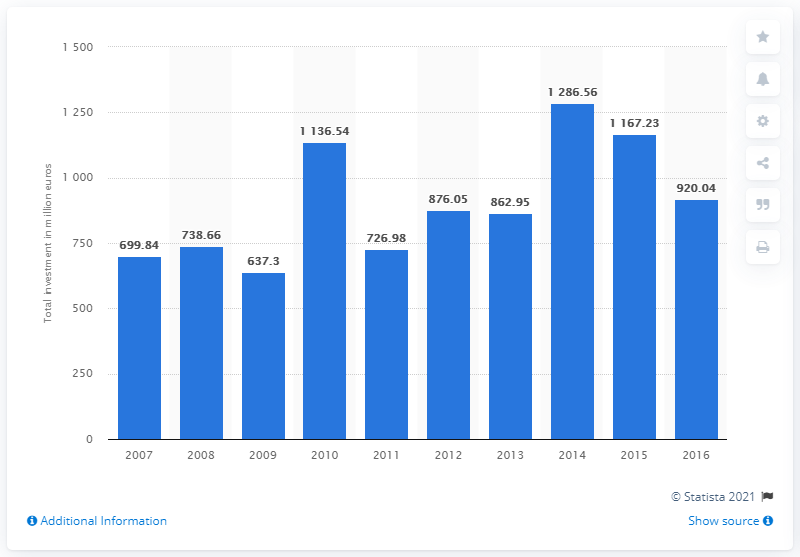Highlight a few significant elements in this photo. In 2014, the total value of private equity investments was 1,286.56. In 2016, the value of private equity investments was approximately 920.04. 